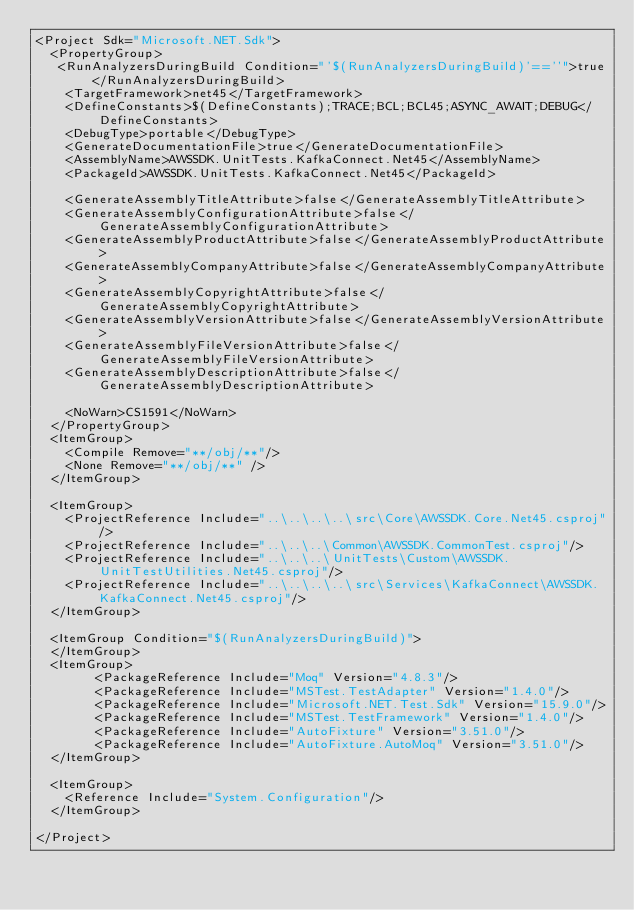Convert code to text. <code><loc_0><loc_0><loc_500><loc_500><_XML_><Project Sdk="Microsoft.NET.Sdk">
  <PropertyGroup>
   <RunAnalyzersDuringBuild Condition="'$(RunAnalyzersDuringBuild)'==''">true</RunAnalyzersDuringBuild>
    <TargetFramework>net45</TargetFramework>
    <DefineConstants>$(DefineConstants);TRACE;BCL;BCL45;ASYNC_AWAIT;DEBUG</DefineConstants>
    <DebugType>portable</DebugType>
    <GenerateDocumentationFile>true</GenerateDocumentationFile>
    <AssemblyName>AWSSDK.UnitTests.KafkaConnect.Net45</AssemblyName>
    <PackageId>AWSSDK.UnitTests.KafkaConnect.Net45</PackageId>

    <GenerateAssemblyTitleAttribute>false</GenerateAssemblyTitleAttribute>
    <GenerateAssemblyConfigurationAttribute>false</GenerateAssemblyConfigurationAttribute>
    <GenerateAssemblyProductAttribute>false</GenerateAssemblyProductAttribute>
    <GenerateAssemblyCompanyAttribute>false</GenerateAssemblyCompanyAttribute>
    <GenerateAssemblyCopyrightAttribute>false</GenerateAssemblyCopyrightAttribute>
    <GenerateAssemblyVersionAttribute>false</GenerateAssemblyVersionAttribute>
    <GenerateAssemblyFileVersionAttribute>false</GenerateAssemblyFileVersionAttribute>
    <GenerateAssemblyDescriptionAttribute>false</GenerateAssemblyDescriptionAttribute>

    <NoWarn>CS1591</NoWarn>
  </PropertyGroup>
  <ItemGroup>
    <Compile Remove="**/obj/**"/>
    <None Remove="**/obj/**" />
  </ItemGroup>

  <ItemGroup>
    <ProjectReference Include="..\..\..\..\src\Core\AWSSDK.Core.Net45.csproj"/>
    <ProjectReference Include="..\..\..\Common\AWSSDK.CommonTest.csproj"/>
    <ProjectReference Include="..\..\..\UnitTests\Custom\AWSSDK.UnitTestUtilities.Net45.csproj"/>
    <ProjectReference Include="..\..\..\..\src\Services\KafkaConnect\AWSSDK.KafkaConnect.Net45.csproj"/>
  </ItemGroup>

  <ItemGroup Condition="$(RunAnalyzersDuringBuild)">
  </ItemGroup>
  <ItemGroup>
        <PackageReference Include="Moq" Version="4.8.3"/>
        <PackageReference Include="MSTest.TestAdapter" Version="1.4.0"/>
        <PackageReference Include="Microsoft.NET.Test.Sdk" Version="15.9.0"/>
        <PackageReference Include="MSTest.TestFramework" Version="1.4.0"/>
        <PackageReference Include="AutoFixture" Version="3.51.0"/>
        <PackageReference Include="AutoFixture.AutoMoq" Version="3.51.0"/>
  </ItemGroup>

  <ItemGroup>
    <Reference Include="System.Configuration"/>
  </ItemGroup>

</Project></code> 